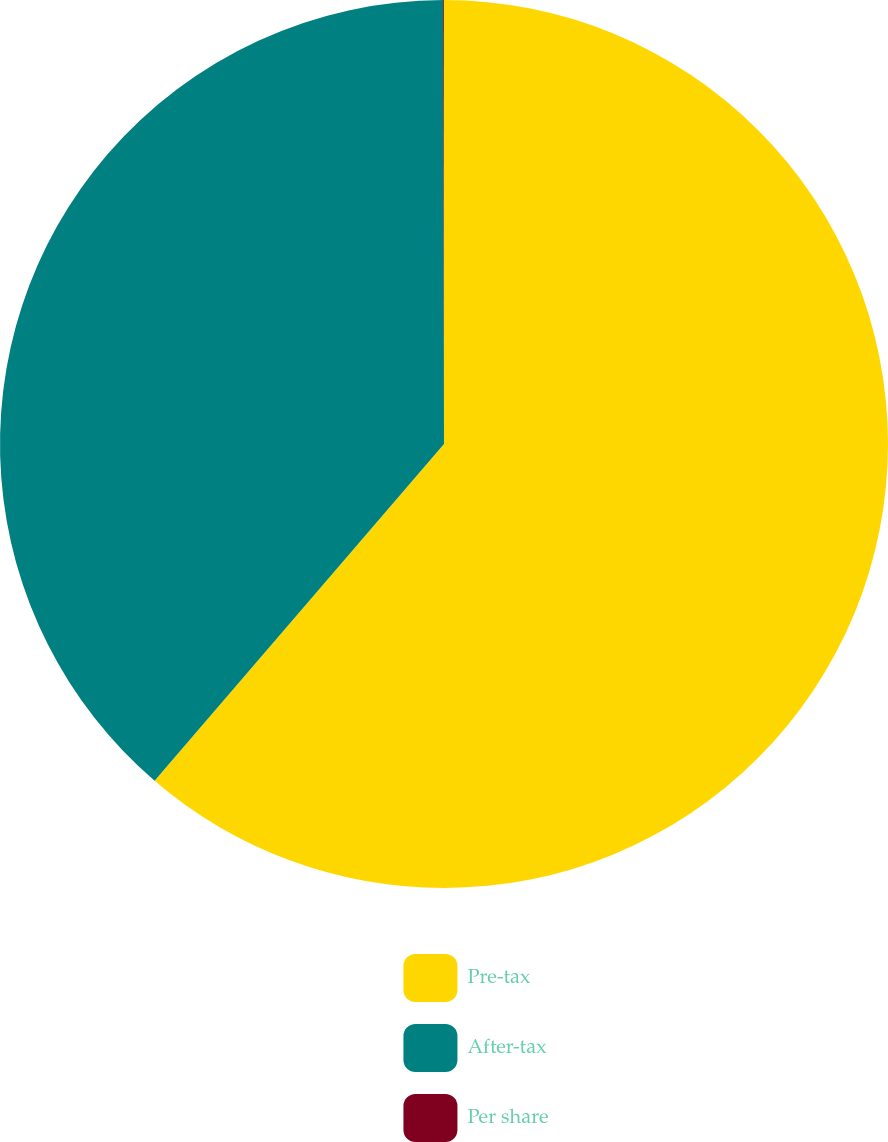Convert chart to OTSL. <chart><loc_0><loc_0><loc_500><loc_500><pie_chart><fcel>Pre-tax<fcel>After-tax<fcel>Per share<nl><fcel>61.3%<fcel>38.67%<fcel>0.03%<nl></chart> 